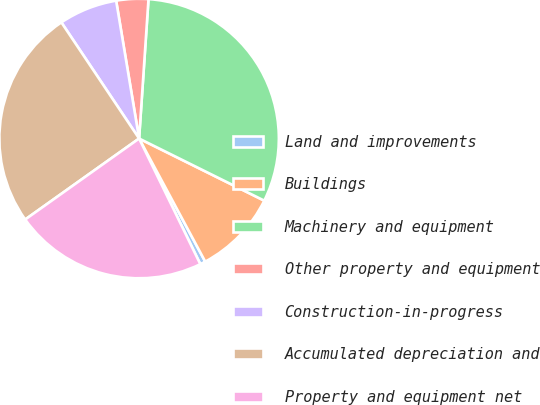<chart> <loc_0><loc_0><loc_500><loc_500><pie_chart><fcel>Land and improvements<fcel>Buildings<fcel>Machinery and equipment<fcel>Other property and equipment<fcel>Construction-in-progress<fcel>Accumulated depreciation and<fcel>Property and equipment net<nl><fcel>0.63%<fcel>9.82%<fcel>31.26%<fcel>3.7%<fcel>6.76%<fcel>25.45%<fcel>22.38%<nl></chart> 